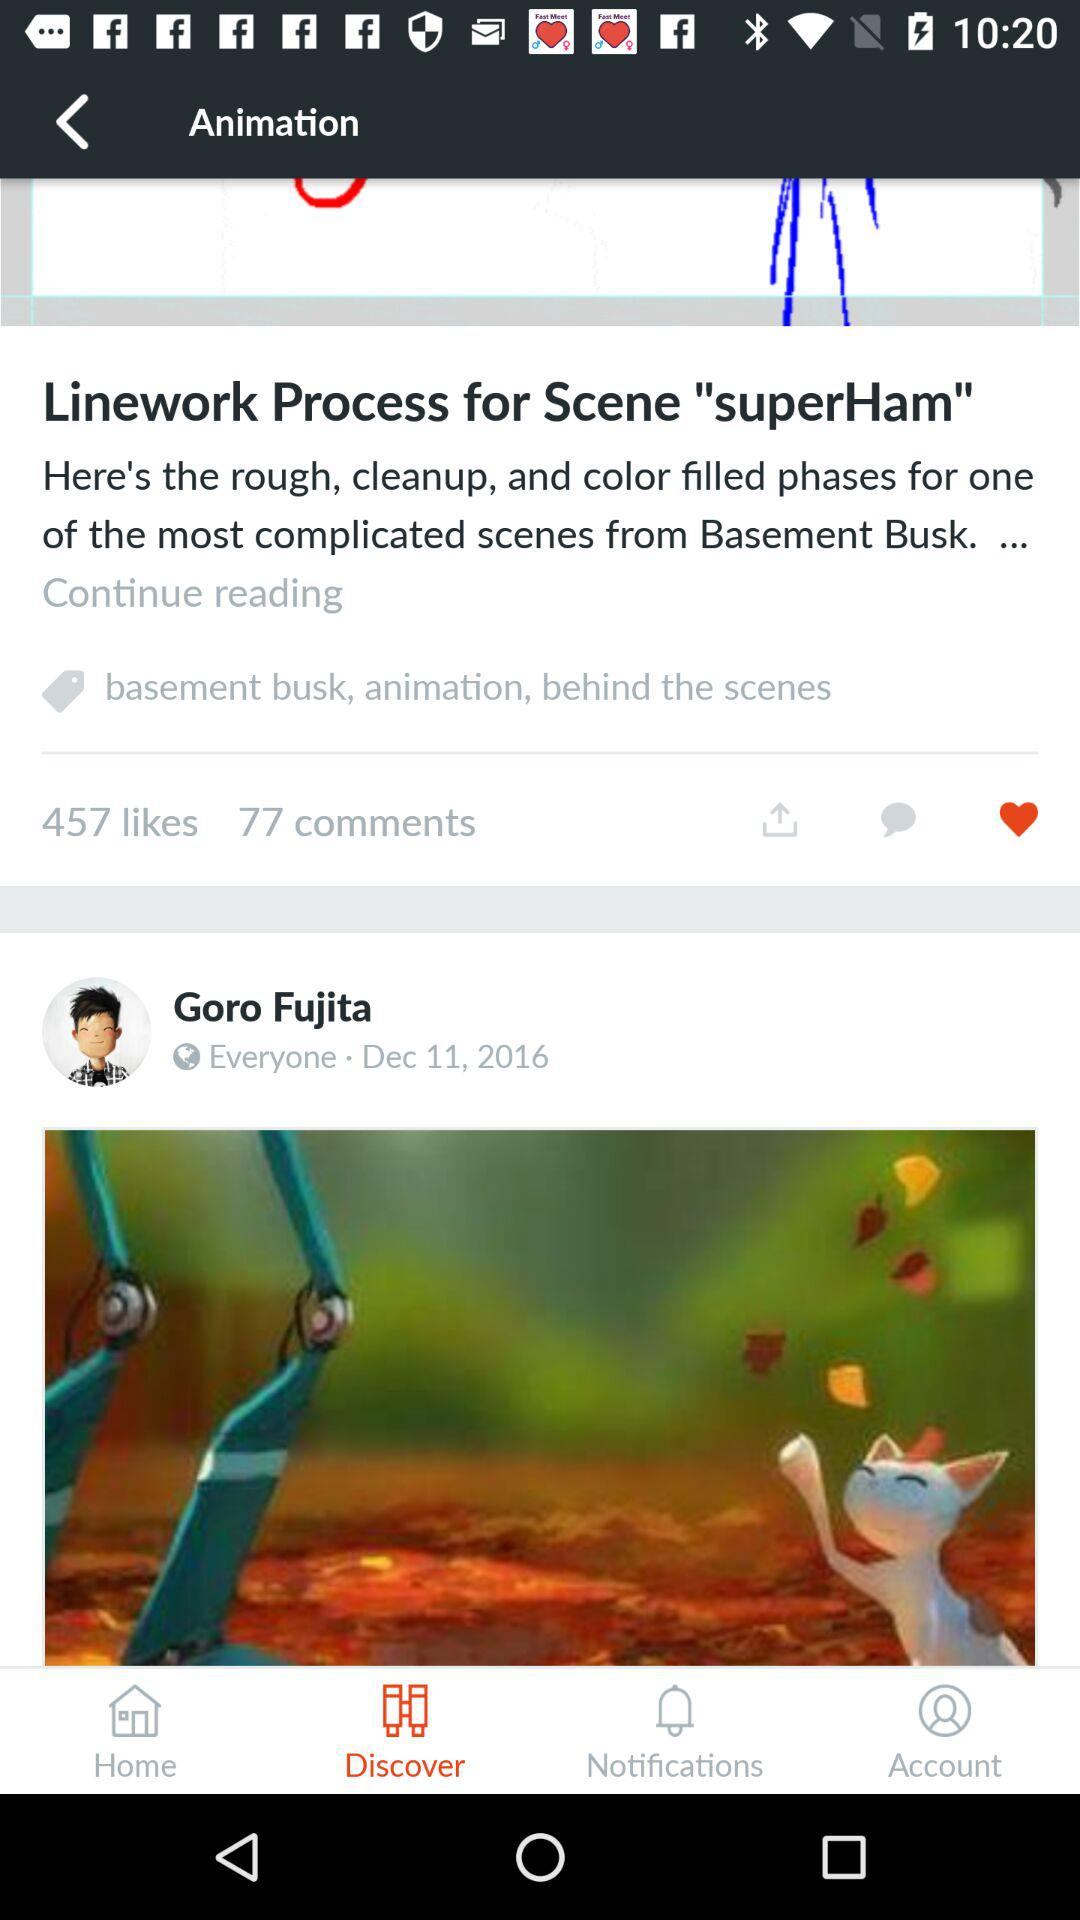What is the posted date of the post by Goro Fujita? The posted date is December 11, 2016. 